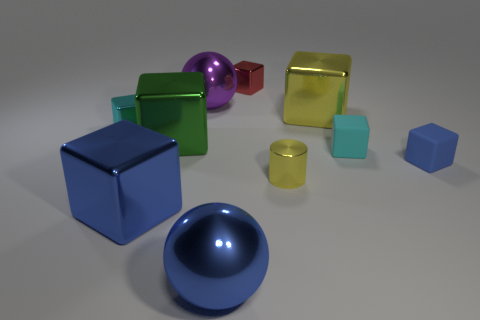Subtract all large yellow blocks. How many blocks are left? 6 Subtract 2 spheres. How many spheres are left? 0 Subtract all green cubes. How many cubes are left? 6 Subtract all brown balls. How many blue blocks are left? 2 Subtract all red metallic cubes. Subtract all big metallic things. How many objects are left? 4 Add 6 large metallic balls. How many large metallic balls are left? 8 Add 4 large blue metallic blocks. How many large blue metallic blocks exist? 5 Subtract 0 gray spheres. How many objects are left? 10 Subtract all cylinders. How many objects are left? 9 Subtract all cyan cylinders. Subtract all yellow balls. How many cylinders are left? 1 